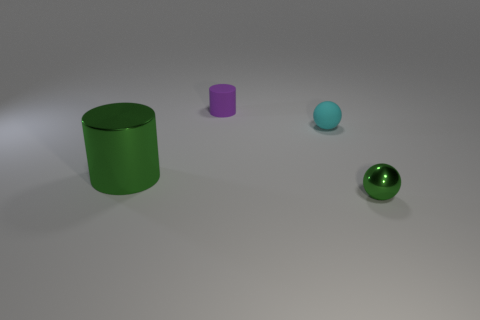Subtract all yellow spheres. Subtract all blue cylinders. How many spheres are left? 2 Add 3 gray rubber balls. How many objects exist? 7 Add 2 big gray rubber cylinders. How many big gray rubber cylinders exist? 2 Subtract 0 yellow spheres. How many objects are left? 4 Subtract all red things. Subtract all small cyan spheres. How many objects are left? 3 Add 2 metal things. How many metal things are left? 4 